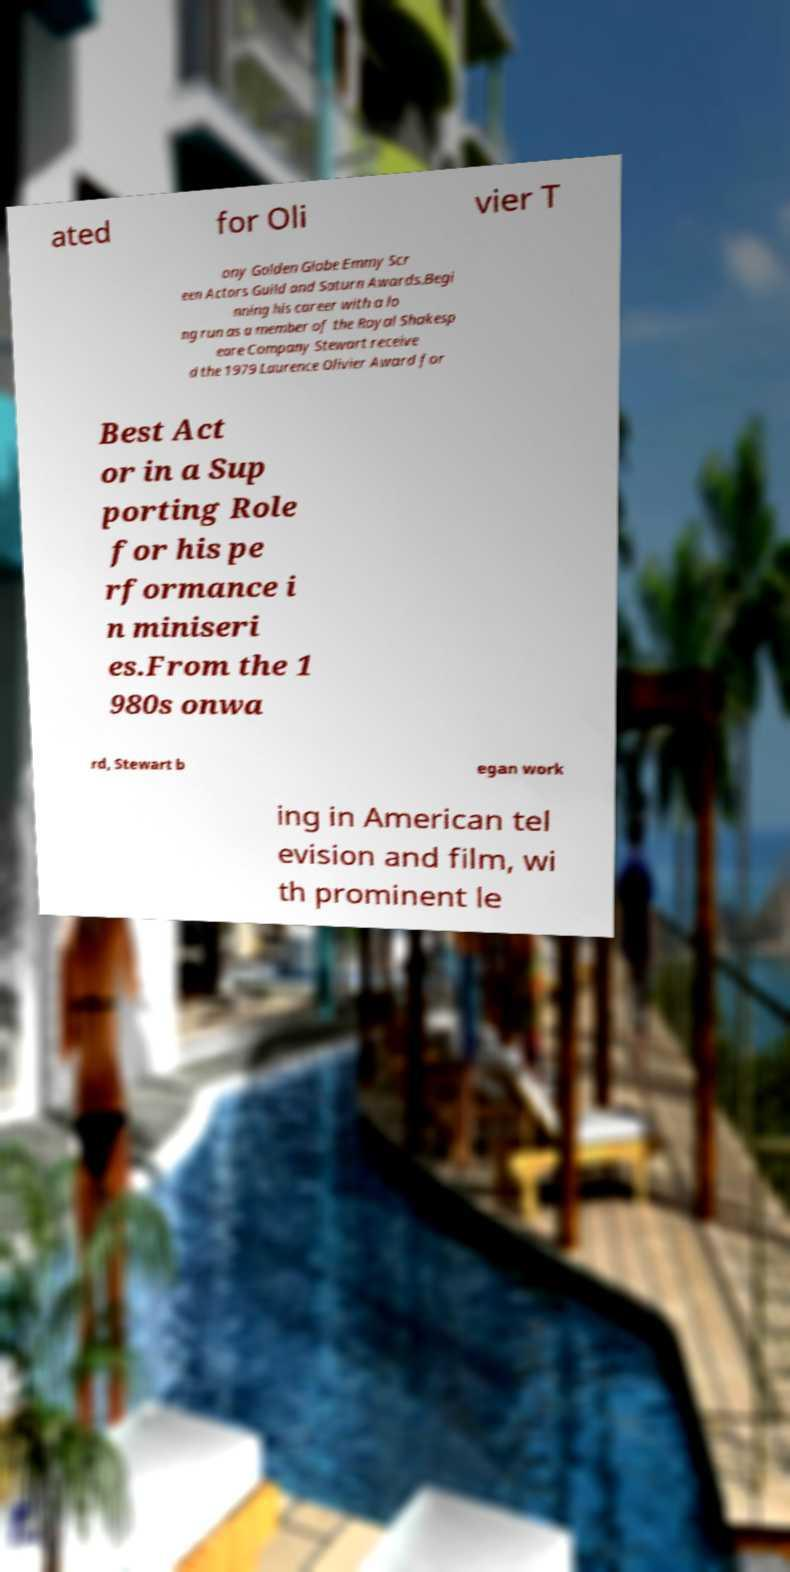Could you assist in decoding the text presented in this image and type it out clearly? ated for Oli vier T ony Golden Globe Emmy Scr een Actors Guild and Saturn Awards.Begi nning his career with a lo ng run as a member of the Royal Shakesp eare Company Stewart receive d the 1979 Laurence Olivier Award for Best Act or in a Sup porting Role for his pe rformance i n miniseri es.From the 1 980s onwa rd, Stewart b egan work ing in American tel evision and film, wi th prominent le 